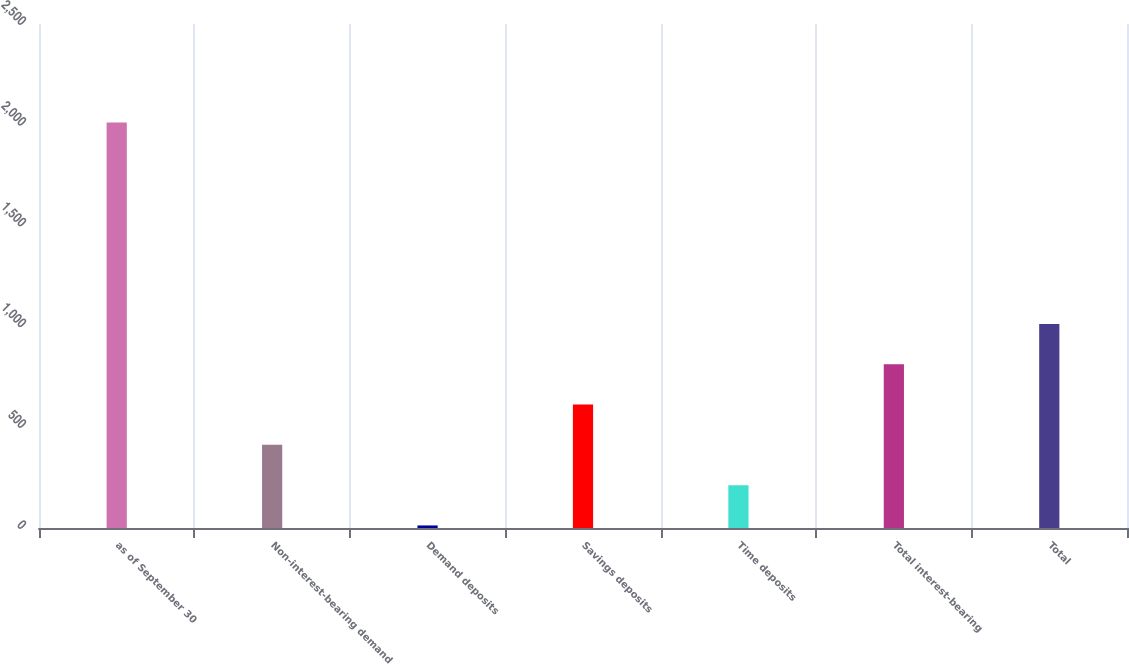Convert chart. <chart><loc_0><loc_0><loc_500><loc_500><bar_chart><fcel>as of September 30<fcel>Non-interest-bearing demand<fcel>Demand deposits<fcel>Savings deposits<fcel>Time deposits<fcel>Total interest-bearing<fcel>Total<nl><fcel>2012<fcel>412.56<fcel>12.7<fcel>612.49<fcel>212.63<fcel>812.42<fcel>1012.35<nl></chart> 